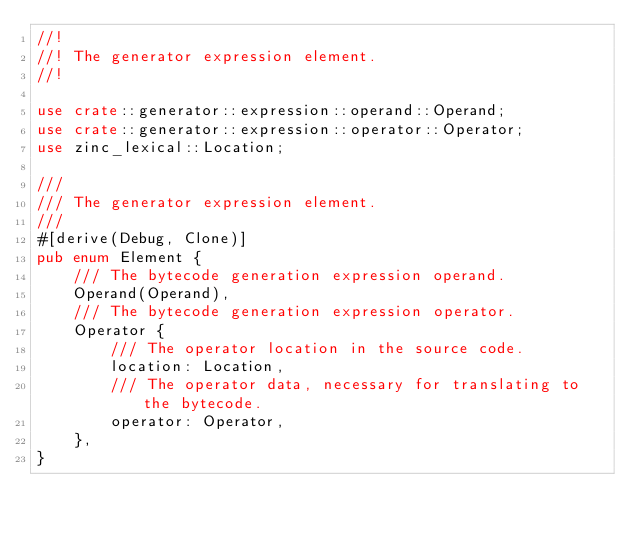Convert code to text. <code><loc_0><loc_0><loc_500><loc_500><_Rust_>//!
//! The generator expression element.
//!

use crate::generator::expression::operand::Operand;
use crate::generator::expression::operator::Operator;
use zinc_lexical::Location;

///
/// The generator expression element.
///
#[derive(Debug, Clone)]
pub enum Element {
    /// The bytecode generation expression operand.
    Operand(Operand),
    /// The bytecode generation expression operator.
    Operator {
        /// The operator location in the source code.
        location: Location,
        /// The operator data, necessary for translating to the bytecode.
        operator: Operator,
    },
}
</code> 